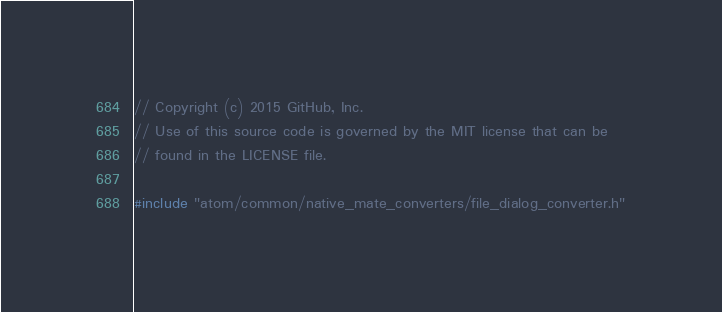<code> <loc_0><loc_0><loc_500><loc_500><_C++_>// Copyright (c) 2015 GitHub, Inc.
// Use of this source code is governed by the MIT license that can be
// found in the LICENSE file.

#include "atom/common/native_mate_converters/file_dialog_converter.h"
</code> 